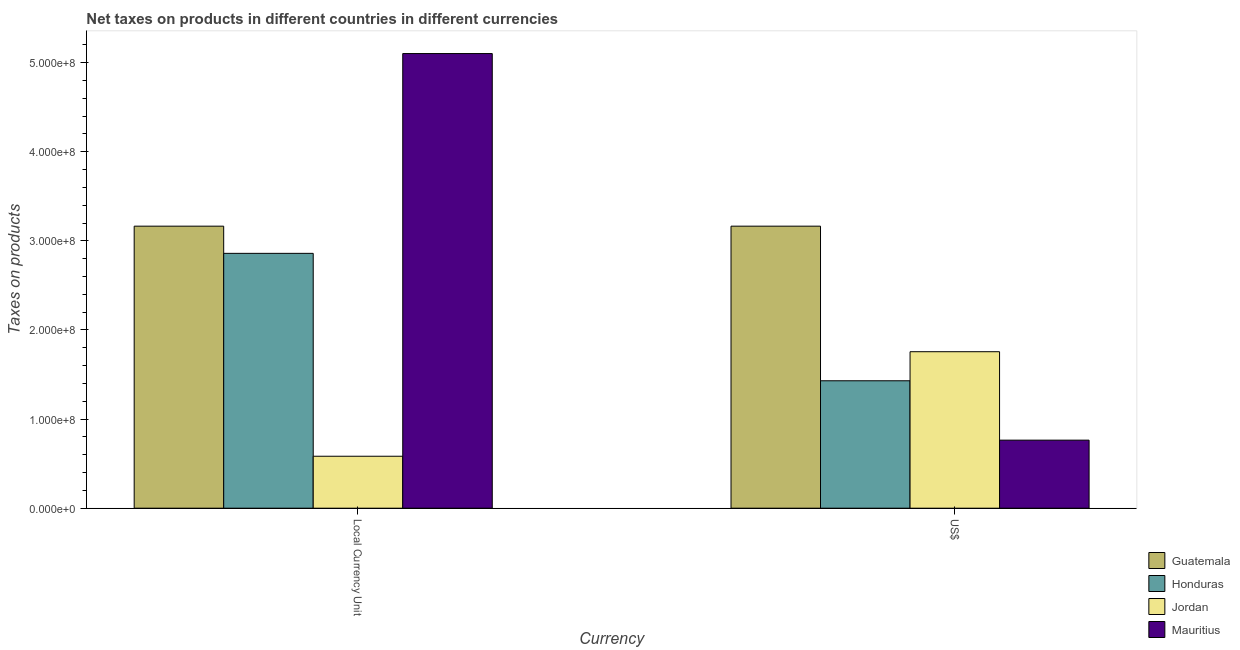How many different coloured bars are there?
Offer a very short reply. 4. Are the number of bars on each tick of the X-axis equal?
Offer a terse response. Yes. How many bars are there on the 1st tick from the left?
Make the answer very short. 4. How many bars are there on the 1st tick from the right?
Make the answer very short. 4. What is the label of the 2nd group of bars from the left?
Ensure brevity in your answer.  US$. What is the net taxes in constant 2005 us$ in Guatemala?
Keep it short and to the point. 3.16e+08. Across all countries, what is the maximum net taxes in us$?
Offer a terse response. 3.16e+08. Across all countries, what is the minimum net taxes in constant 2005 us$?
Provide a succinct answer. 5.83e+07. In which country was the net taxes in constant 2005 us$ maximum?
Provide a succinct answer. Mauritius. In which country was the net taxes in us$ minimum?
Keep it short and to the point. Mauritius. What is the total net taxes in constant 2005 us$ in the graph?
Ensure brevity in your answer.  1.17e+09. What is the difference between the net taxes in us$ in Guatemala and that in Honduras?
Your response must be concise. 1.74e+08. What is the difference between the net taxes in constant 2005 us$ in Jordan and the net taxes in us$ in Honduras?
Make the answer very short. -8.47e+07. What is the average net taxes in constant 2005 us$ per country?
Your answer should be very brief. 2.93e+08. What is the difference between the net taxes in us$ and net taxes in constant 2005 us$ in Honduras?
Offer a terse response. -1.43e+08. In how many countries, is the net taxes in constant 2005 us$ greater than 320000000 units?
Provide a succinct answer. 1. What is the ratio of the net taxes in constant 2005 us$ in Jordan to that in Mauritius?
Offer a terse response. 0.11. Is the net taxes in constant 2005 us$ in Mauritius less than that in Jordan?
Ensure brevity in your answer.  No. In how many countries, is the net taxes in us$ greater than the average net taxes in us$ taken over all countries?
Ensure brevity in your answer.  1. What does the 2nd bar from the left in Local Currency Unit represents?
Ensure brevity in your answer.  Honduras. What does the 1st bar from the right in Local Currency Unit represents?
Offer a terse response. Mauritius. How many bars are there?
Offer a very short reply. 8. Are all the bars in the graph horizontal?
Offer a very short reply. No. Are the values on the major ticks of Y-axis written in scientific E-notation?
Ensure brevity in your answer.  Yes. Does the graph contain grids?
Your answer should be compact. No. What is the title of the graph?
Your answer should be compact. Net taxes on products in different countries in different currencies. What is the label or title of the X-axis?
Provide a succinct answer. Currency. What is the label or title of the Y-axis?
Ensure brevity in your answer.  Taxes on products. What is the Taxes on products in Guatemala in Local Currency Unit?
Offer a very short reply. 3.16e+08. What is the Taxes on products in Honduras in Local Currency Unit?
Offer a very short reply. 2.86e+08. What is the Taxes on products of Jordan in Local Currency Unit?
Offer a terse response. 5.83e+07. What is the Taxes on products in Mauritius in Local Currency Unit?
Make the answer very short. 5.10e+08. What is the Taxes on products in Guatemala in US$?
Offer a terse response. 3.16e+08. What is the Taxes on products in Honduras in US$?
Provide a succinct answer. 1.43e+08. What is the Taxes on products of Jordan in US$?
Provide a succinct answer. 1.76e+08. What is the Taxes on products in Mauritius in US$?
Offer a terse response. 7.64e+07. Across all Currency, what is the maximum Taxes on products of Guatemala?
Offer a very short reply. 3.16e+08. Across all Currency, what is the maximum Taxes on products in Honduras?
Provide a short and direct response. 2.86e+08. Across all Currency, what is the maximum Taxes on products in Jordan?
Your answer should be very brief. 1.76e+08. Across all Currency, what is the maximum Taxes on products of Mauritius?
Your answer should be very brief. 5.10e+08. Across all Currency, what is the minimum Taxes on products in Guatemala?
Provide a succinct answer. 3.16e+08. Across all Currency, what is the minimum Taxes on products of Honduras?
Offer a very short reply. 1.43e+08. Across all Currency, what is the minimum Taxes on products of Jordan?
Provide a short and direct response. 5.83e+07. Across all Currency, what is the minimum Taxes on products in Mauritius?
Make the answer very short. 7.64e+07. What is the total Taxes on products of Guatemala in the graph?
Your answer should be very brief. 6.33e+08. What is the total Taxes on products of Honduras in the graph?
Your response must be concise. 4.29e+08. What is the total Taxes on products of Jordan in the graph?
Provide a succinct answer. 2.34e+08. What is the total Taxes on products of Mauritius in the graph?
Your answer should be very brief. 5.87e+08. What is the difference between the Taxes on products of Guatemala in Local Currency Unit and that in US$?
Your answer should be compact. 0. What is the difference between the Taxes on products in Honduras in Local Currency Unit and that in US$?
Offer a terse response. 1.43e+08. What is the difference between the Taxes on products in Jordan in Local Currency Unit and that in US$?
Make the answer very short. -1.17e+08. What is the difference between the Taxes on products of Mauritius in Local Currency Unit and that in US$?
Your answer should be very brief. 4.34e+08. What is the difference between the Taxes on products in Guatemala in Local Currency Unit and the Taxes on products in Honduras in US$?
Ensure brevity in your answer.  1.74e+08. What is the difference between the Taxes on products in Guatemala in Local Currency Unit and the Taxes on products in Jordan in US$?
Provide a short and direct response. 1.41e+08. What is the difference between the Taxes on products of Guatemala in Local Currency Unit and the Taxes on products of Mauritius in US$?
Provide a short and direct response. 2.40e+08. What is the difference between the Taxes on products of Honduras in Local Currency Unit and the Taxes on products of Jordan in US$?
Your answer should be compact. 1.10e+08. What is the difference between the Taxes on products of Honduras in Local Currency Unit and the Taxes on products of Mauritius in US$?
Your answer should be compact. 2.10e+08. What is the difference between the Taxes on products of Jordan in Local Currency Unit and the Taxes on products of Mauritius in US$?
Your response must be concise. -1.81e+07. What is the average Taxes on products in Guatemala per Currency?
Keep it short and to the point. 3.16e+08. What is the average Taxes on products of Honduras per Currency?
Offer a terse response. 2.14e+08. What is the average Taxes on products of Jordan per Currency?
Give a very brief answer. 1.17e+08. What is the average Taxes on products in Mauritius per Currency?
Offer a terse response. 2.93e+08. What is the difference between the Taxes on products in Guatemala and Taxes on products in Honduras in Local Currency Unit?
Your answer should be very brief. 3.05e+07. What is the difference between the Taxes on products in Guatemala and Taxes on products in Jordan in Local Currency Unit?
Provide a short and direct response. 2.58e+08. What is the difference between the Taxes on products of Guatemala and Taxes on products of Mauritius in Local Currency Unit?
Your answer should be very brief. -1.94e+08. What is the difference between the Taxes on products in Honduras and Taxes on products in Jordan in Local Currency Unit?
Give a very brief answer. 2.28e+08. What is the difference between the Taxes on products of Honduras and Taxes on products of Mauritius in Local Currency Unit?
Offer a terse response. -2.24e+08. What is the difference between the Taxes on products in Jordan and Taxes on products in Mauritius in Local Currency Unit?
Provide a short and direct response. -4.52e+08. What is the difference between the Taxes on products of Guatemala and Taxes on products of Honduras in US$?
Your answer should be compact. 1.74e+08. What is the difference between the Taxes on products in Guatemala and Taxes on products in Jordan in US$?
Your response must be concise. 1.41e+08. What is the difference between the Taxes on products of Guatemala and Taxes on products of Mauritius in US$?
Offer a very short reply. 2.40e+08. What is the difference between the Taxes on products in Honduras and Taxes on products in Jordan in US$?
Give a very brief answer. -3.26e+07. What is the difference between the Taxes on products in Honduras and Taxes on products in Mauritius in US$?
Ensure brevity in your answer.  6.66e+07. What is the difference between the Taxes on products of Jordan and Taxes on products of Mauritius in US$?
Your response must be concise. 9.92e+07. What is the ratio of the Taxes on products of Guatemala in Local Currency Unit to that in US$?
Give a very brief answer. 1. What is the ratio of the Taxes on products of Jordan in Local Currency Unit to that in US$?
Make the answer very short. 0.33. What is the ratio of the Taxes on products in Mauritius in Local Currency Unit to that in US$?
Keep it short and to the point. 6.68. What is the difference between the highest and the second highest Taxes on products of Honduras?
Provide a succinct answer. 1.43e+08. What is the difference between the highest and the second highest Taxes on products in Jordan?
Make the answer very short. 1.17e+08. What is the difference between the highest and the second highest Taxes on products of Mauritius?
Your response must be concise. 4.34e+08. What is the difference between the highest and the lowest Taxes on products in Honduras?
Your answer should be very brief. 1.43e+08. What is the difference between the highest and the lowest Taxes on products of Jordan?
Make the answer very short. 1.17e+08. What is the difference between the highest and the lowest Taxes on products in Mauritius?
Ensure brevity in your answer.  4.34e+08. 